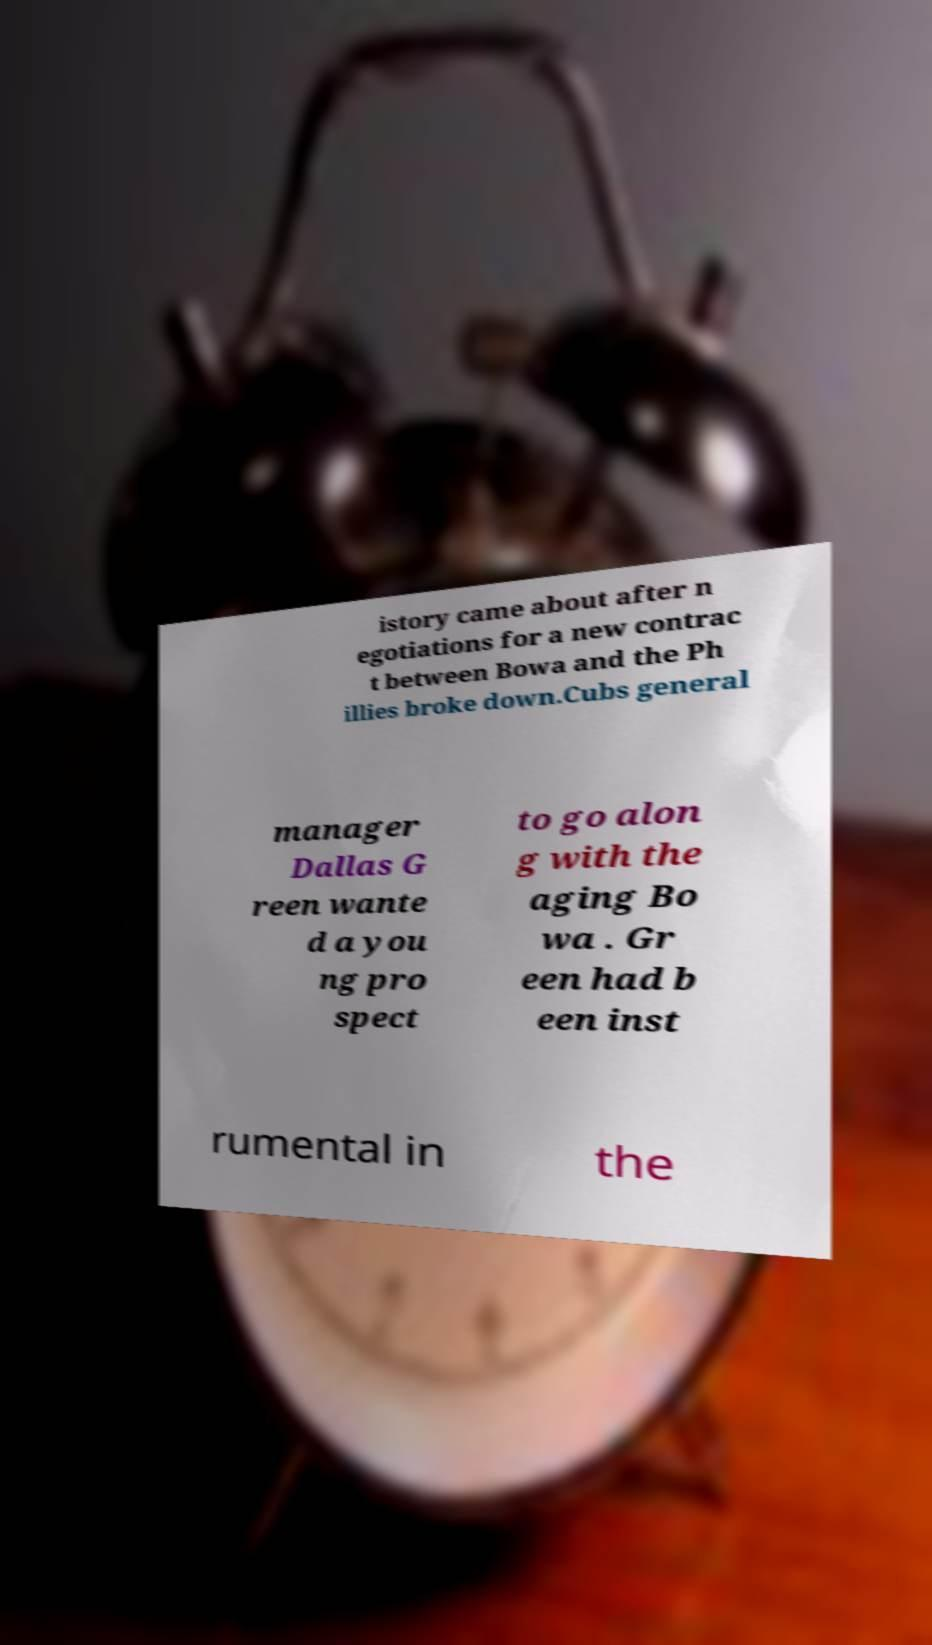Could you assist in decoding the text presented in this image and type it out clearly? istory came about after n egotiations for a new contrac t between Bowa and the Ph illies broke down.Cubs general manager Dallas G reen wante d a you ng pro spect to go alon g with the aging Bo wa . Gr een had b een inst rumental in the 